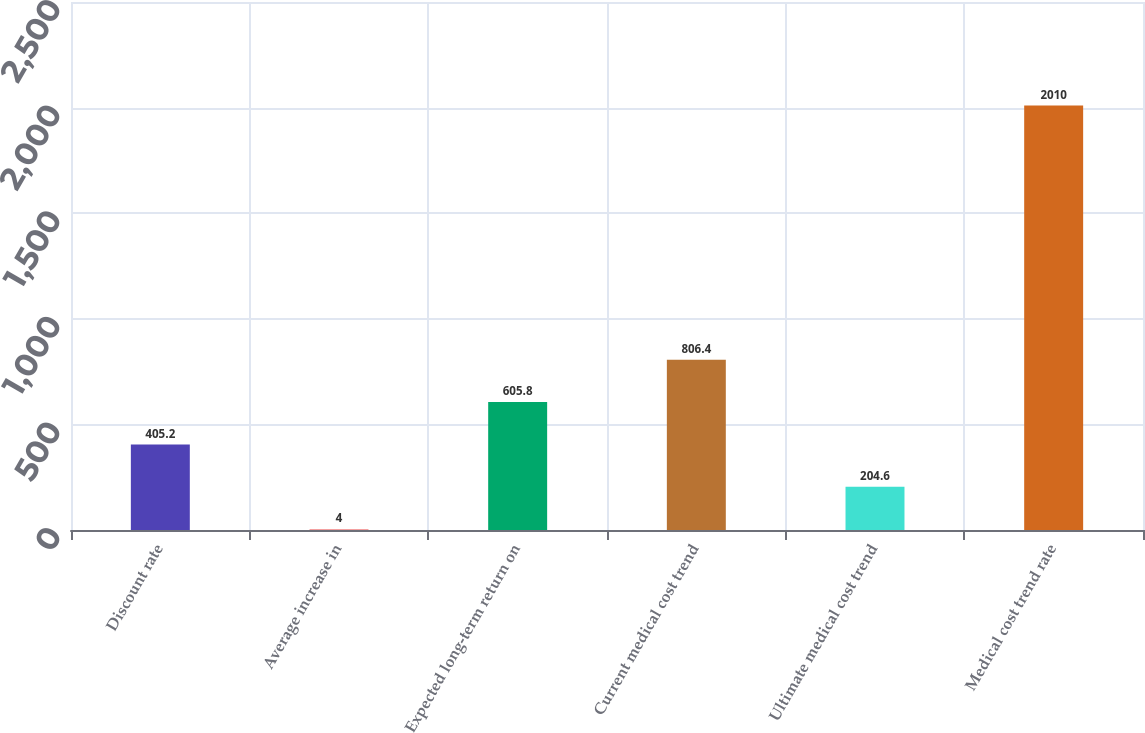<chart> <loc_0><loc_0><loc_500><loc_500><bar_chart><fcel>Discount rate<fcel>Average increase in<fcel>Expected long-term return on<fcel>Current medical cost trend<fcel>Ultimate medical cost trend<fcel>Medical cost trend rate<nl><fcel>405.2<fcel>4<fcel>605.8<fcel>806.4<fcel>204.6<fcel>2010<nl></chart> 